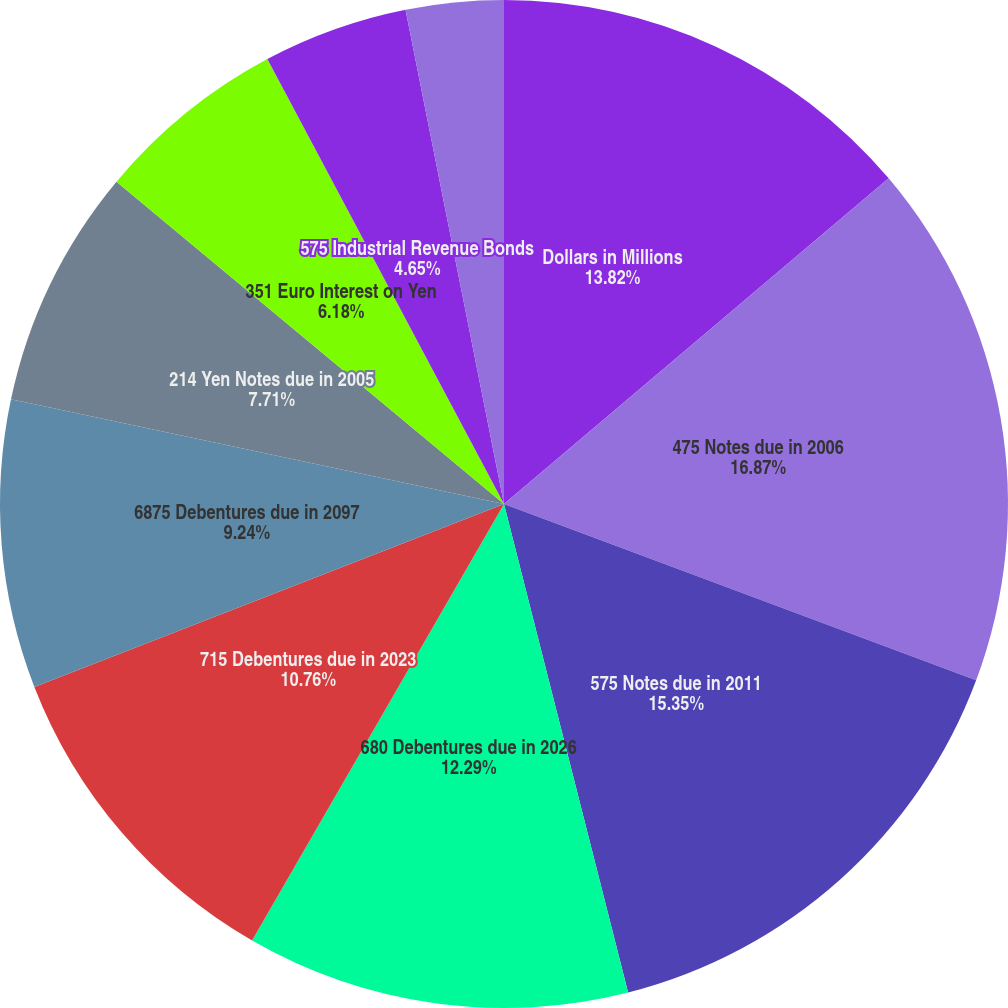Convert chart. <chart><loc_0><loc_0><loc_500><loc_500><pie_chart><fcel>Dollars in Millions<fcel>475 Notes due in 2006<fcel>575 Notes due in 2011<fcel>680 Debentures due in 2026<fcel>715 Debentures due in 2023<fcel>6875 Debentures due in 2097<fcel>214 Yen Notes due in 2005<fcel>351 Euro Interest on Yen<fcel>575 Industrial Revenue Bonds<fcel>Variable Rate Industrial<nl><fcel>13.82%<fcel>16.87%<fcel>15.35%<fcel>12.29%<fcel>10.76%<fcel>9.24%<fcel>7.71%<fcel>6.18%<fcel>4.65%<fcel>3.13%<nl></chart> 